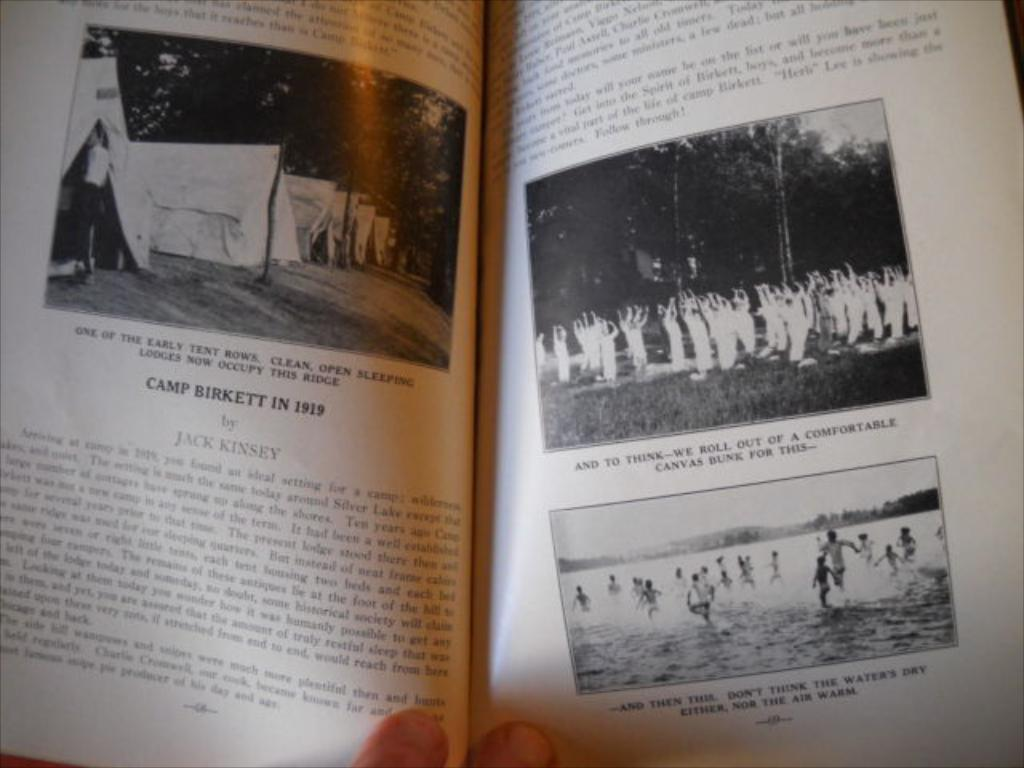<image>
Share a concise interpretation of the image provided. Person holding a booklet that says the year 1919 on it. 